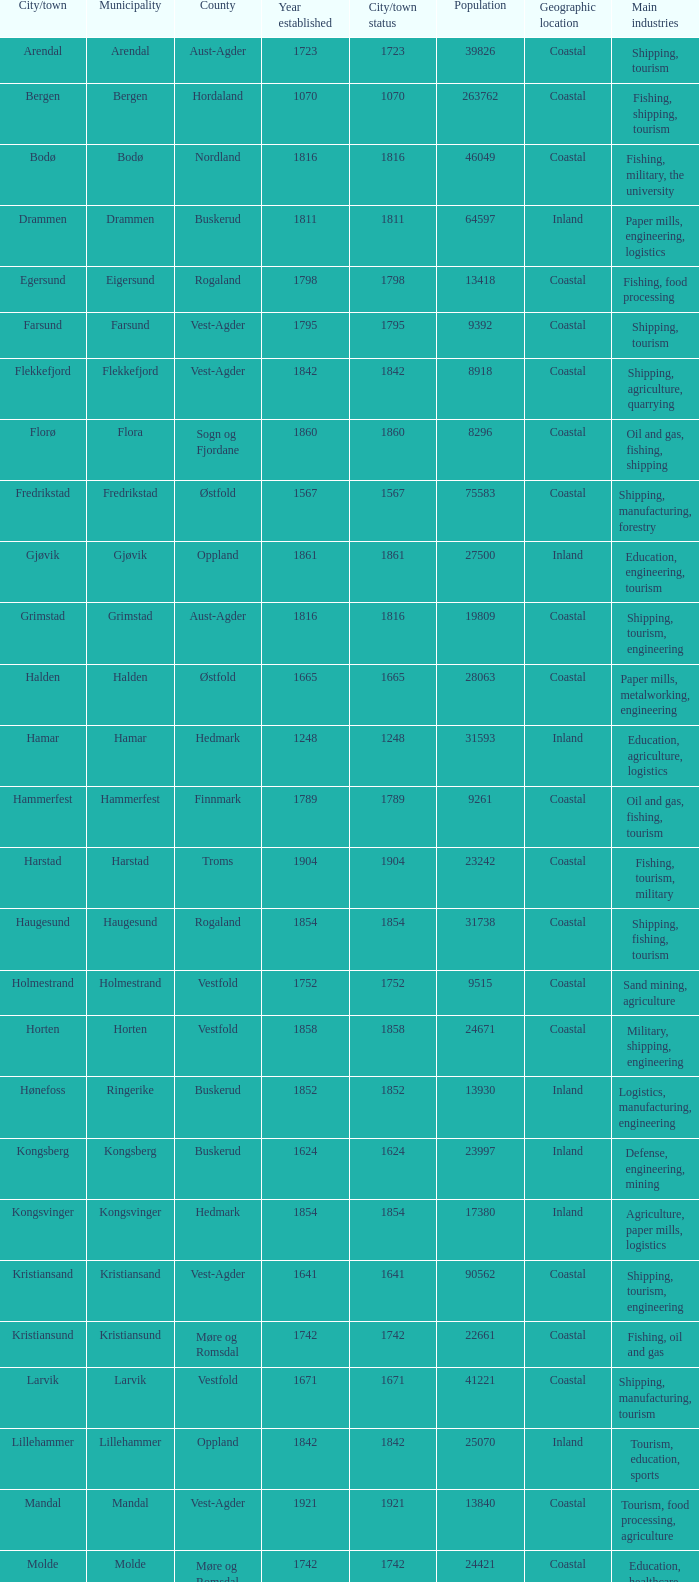Which municipality has a population of 24421? Molde. Parse the full table. {'header': ['City/town', 'Municipality', 'County', 'Year established', 'City/town status', 'Population', 'Geographic location', 'Main industries'], 'rows': [['Arendal', 'Arendal', 'Aust-Agder', '1723', '1723', '39826', 'Coastal', 'Shipping, tourism'], ['Bergen', 'Bergen', 'Hordaland', '1070', '1070', '263762', 'Coastal', 'Fishing, shipping, tourism'], ['Bodø', 'Bodø', 'Nordland', '1816', '1816', '46049', 'Coastal', 'Fishing, military, the university'], ['Drammen', 'Drammen', 'Buskerud', '1811', '1811', '64597', 'Inland', 'Paper mills, engineering, logistics'], ['Egersund', 'Eigersund', 'Rogaland', '1798', '1798', '13418', 'Coastal', 'Fishing, food processing'], ['Farsund', 'Farsund', 'Vest-Agder', '1795', '1795', '9392', 'Coastal', 'Shipping, tourism'], ['Flekkefjord', 'Flekkefjord', 'Vest-Agder', '1842', '1842', '8918', 'Coastal', 'Shipping, agriculture, quarrying'], ['Florø', 'Flora', 'Sogn og Fjordane', '1860', '1860', '8296', 'Coastal', 'Oil and gas, fishing, shipping'], ['Fredrikstad', 'Fredrikstad', 'Østfold', '1567', '1567', '75583', 'Coastal', 'Shipping, manufacturing, forestry'], ['Gjøvik', 'Gjøvik', 'Oppland', '1861', '1861', '27500', 'Inland', 'Education, engineering, tourism'], ['Grimstad', 'Grimstad', 'Aust-Agder', '1816', '1816', '19809', 'Coastal', 'Shipping, tourism, engineering'], ['Halden', 'Halden', 'Østfold', '1665', '1665', '28063', 'Coastal', 'Paper mills, metalworking, engineering'], ['Hamar', 'Hamar', 'Hedmark', '1248', '1248', '31593', 'Inland', 'Education, agriculture, logistics'], ['Hammerfest', 'Hammerfest', 'Finnmark', '1789', '1789', '9261', 'Coastal', 'Oil and gas, fishing, tourism'], ['Harstad', 'Harstad', 'Troms', '1904', '1904', '23242', 'Coastal', 'Fishing, tourism, military'], ['Haugesund', 'Haugesund', 'Rogaland', '1854', '1854', '31738', 'Coastal', 'Shipping, fishing, tourism'], ['Holmestrand', 'Holmestrand', 'Vestfold', '1752', '1752', '9515', 'Coastal', 'Sand mining, agriculture'], ['Horten', 'Horten', 'Vestfold', '1858', '1858', '24671', 'Coastal', 'Military, shipping, engineering'], ['Hønefoss', 'Ringerike', 'Buskerud', '1852', '1852', '13930', 'Inland', 'Logistics, manufacturing, engineering'], ['Kongsberg', 'Kongsberg', 'Buskerud', '1624', '1624', '23997', 'Inland', 'Defense, engineering, mining'], ['Kongsvinger', 'Kongsvinger', 'Hedmark', '1854', '1854', '17380', 'Inland', 'Agriculture, paper mills, logistics'], ['Kristiansand', 'Kristiansand', 'Vest-Agder', '1641', '1641', '90562', 'Coastal', 'Shipping, tourism, engineering'], ['Kristiansund', 'Kristiansund', 'Møre og Romsdal', '1742', '1742', '22661', 'Coastal', 'Fishing, oil and gas'], ['Larvik', 'Larvik', 'Vestfold', '1671', '1671', '41221', 'Coastal', 'Shipping, manufacturing, tourism'], ['Lillehammer', 'Lillehammer', 'Oppland', '1842', '1842', '25070', 'Inland', 'Tourism, education, sports'], ['Mandal', 'Mandal', 'Vest-Agder', '1921', '1921', '13840', 'Coastal', 'Tourism, food processing, agriculture'], ['Molde', 'Molde', 'Møre og Romsdal', '1742', '1742', '24421', 'Coastal', 'Education, healthcare, tourism'], ['Moss', 'Moss', 'Østfold', '1720', '1720', '28800', 'Coastal', 'Shipping, manufacturing, logistics'], ['Namsos', 'Namsos', 'Nord-Trøndelag', '1845', '1845', '12426', 'Coastal', 'Fishing, paper mills, logistics'], ['Narvik', 'Narvik', 'Nordland', '1902', '1902', '18512', 'Coastal', 'Mining, shipping, tourism'], ['Notodden', 'Notodden', 'Telemark', '1913', '1913', '12359', 'Inland', 'Industrial heritage, hydroelectric power'], ['Oslo', 'Oslo', 'Oslo', '1000', '1000', '613285', 'Coastal', 'Finance, technology, shipping'], ['Porsgrunn', 'Porsgrunn', 'Telemark', '1842', '1842', '33550', 'Coastal', 'Chemicals, metalworking, logistics'], ['Risør', 'Risør', 'Aust-Agder', '1630', '1630', '6938', 'Coastal', 'Shipping, tourism, small-scale industries'], ['Sandefjord', 'Sandefjord', 'Vestfold', '1845', '1845', '42333', 'Coastal', 'Shipping, fishing, tourism'], ['Sandnes', 'Sandnes', 'Rogaland', '1860', '1860', '63032', 'Coastal', 'Oil and gas, engineering, tourism'], ['Sarpsborg', 'Sarpsborg', 'Østfold', '1016', '1016', '50115', 'Coastal', 'Paper mills, logistics, manufacturing'], ['Skien', 'Skien', 'Telemark', '1000', '1000', '72537', 'Inland', 'Shipping, manufacturing, healthcare'], ['Stavanger', 'Stavanger', 'Rogaland', '1125', '1125', '127506', 'Coastal', 'Oil and gas, engineering, tourism'], ['Steinkjer', 'Steinkjer', 'Nord-Trøndelag', '1857', '1857', '20672', 'Inland', 'Agriculture, logistics, education'], ['Søgne', 'Søgne', 'Vest-Agder', '1913', '1913', '12509', 'Coastal', 'Shipping, fishing, agriculture'], ['Tromsø', 'Tromsø', 'Troms', '1794', '1794', '64782', 'Coastal', 'Tourism, research, education'], ['Trondheim', 'Trondheim', 'Sør-Trøndelag', '997', '997', '176348', 'Coastal', 'Education, technology, healthcare'], ['Tønsberg', 'Tønsberg', 'Vestfold', '871', '871', '38914', 'Coastal', 'Shipping, tourism, agriculture'], ['Vadsø', 'Vadsø', 'Finnmark', '1833', '1833', '6187', 'Coastal', 'Fishing, administration, logistics'], ['Vardø', 'Vardø', 'Finnmark', '1789', '1789', '2396', 'Coastal', 'Fishing, tourism, administration'], ['Vennesla', 'Vennesla', 'Vest-Agder', '1964', '1964', '13116', 'Inland', 'Woodworking, agriculture, logistics']]} 